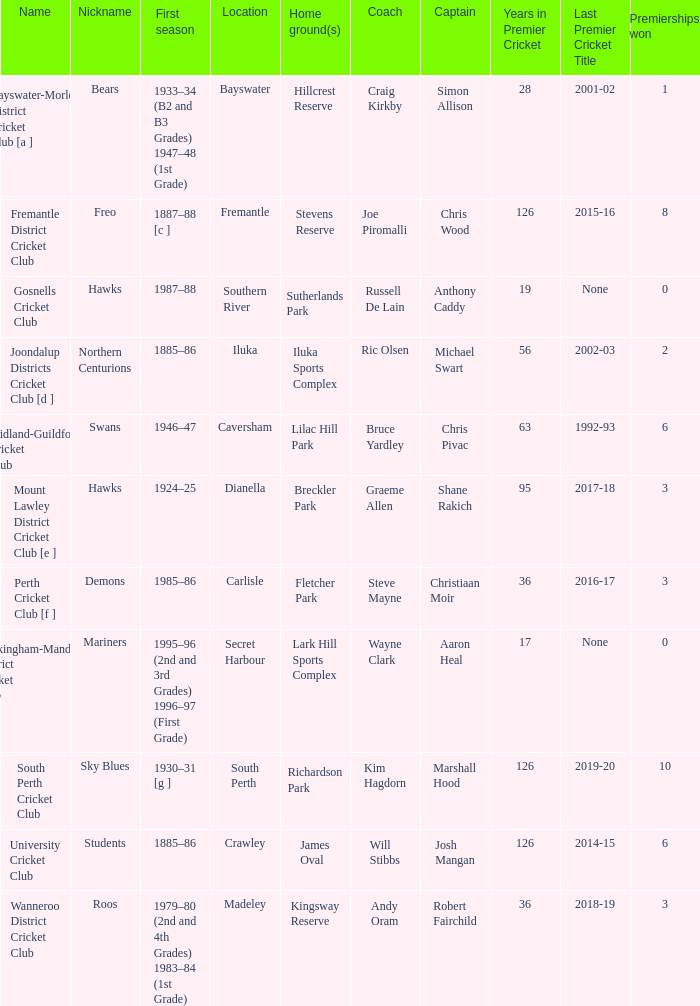What is the location for the club with the nickname the bears? Bayswater. 